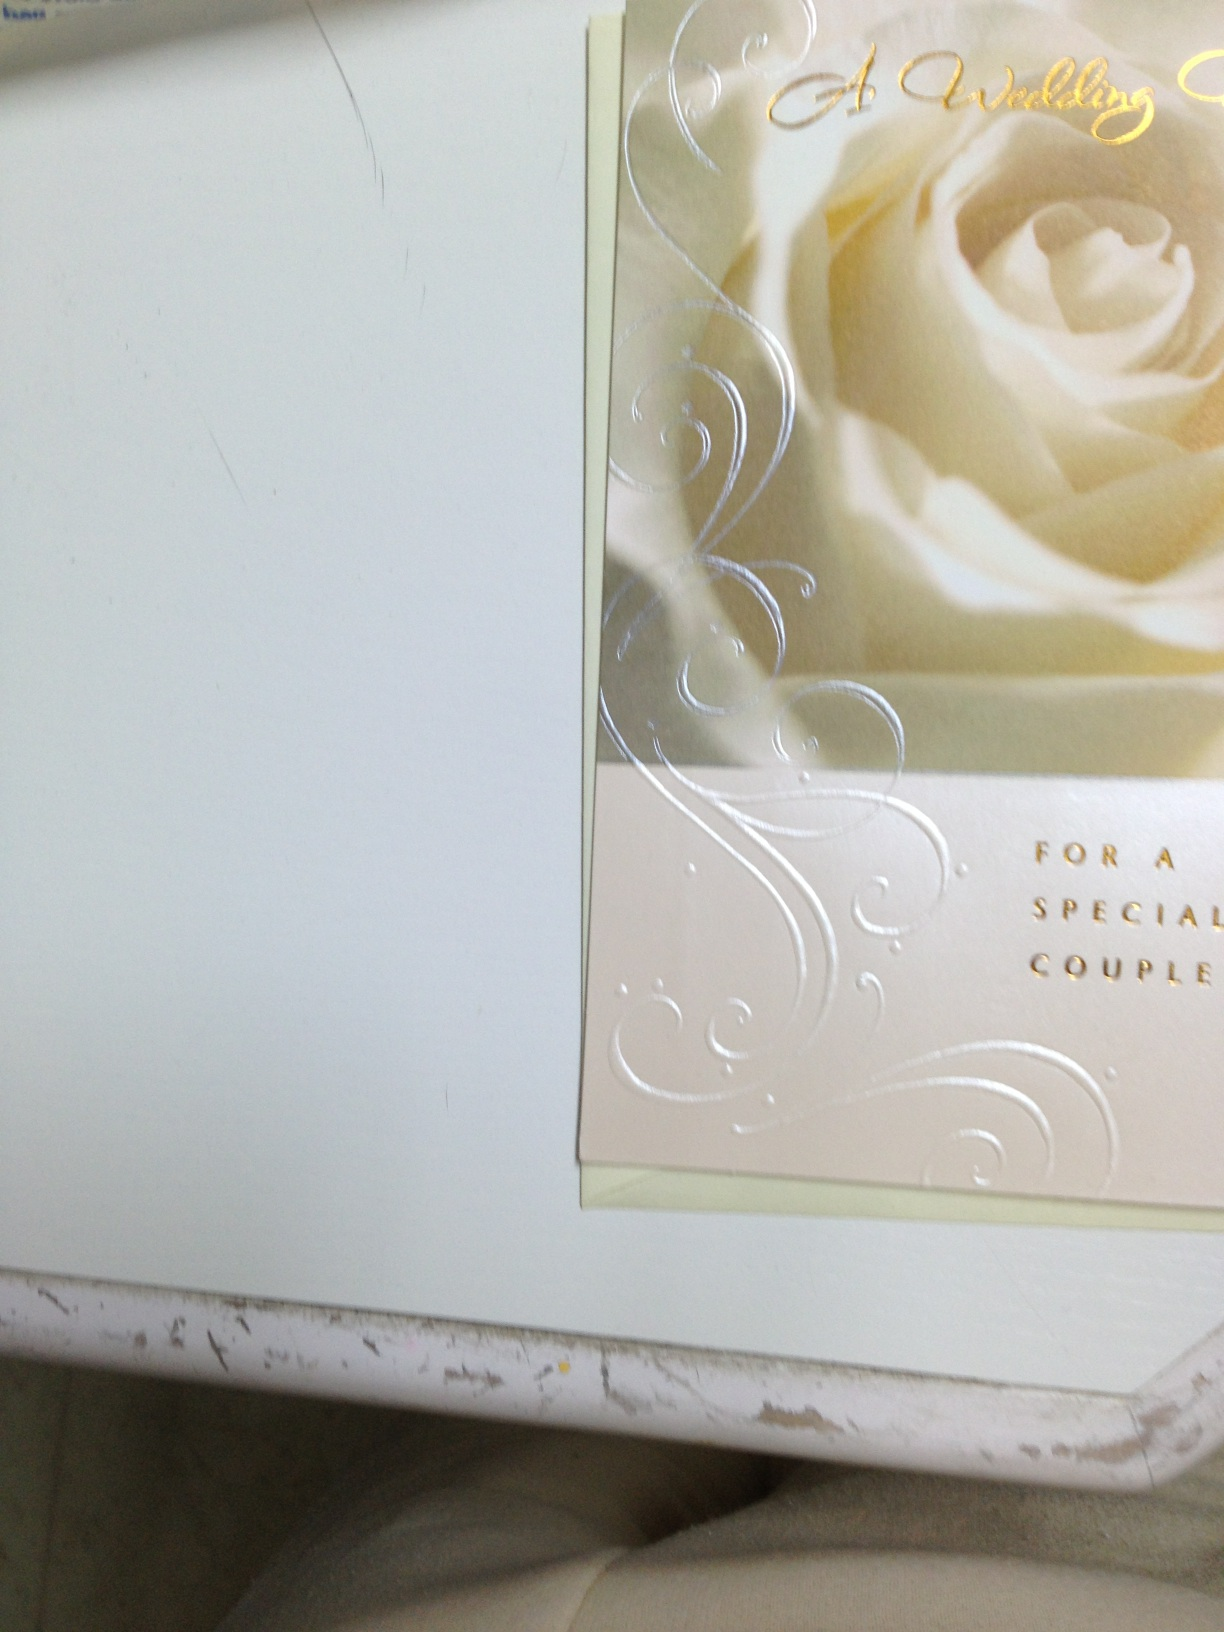What kind of greeting card is this? This is a wedding greeting card designed to congratulate a special couple on their marriage. The card features elegant decorative elements like a rose and swirling patterns with metallic embellishments and a congratulatory message. 